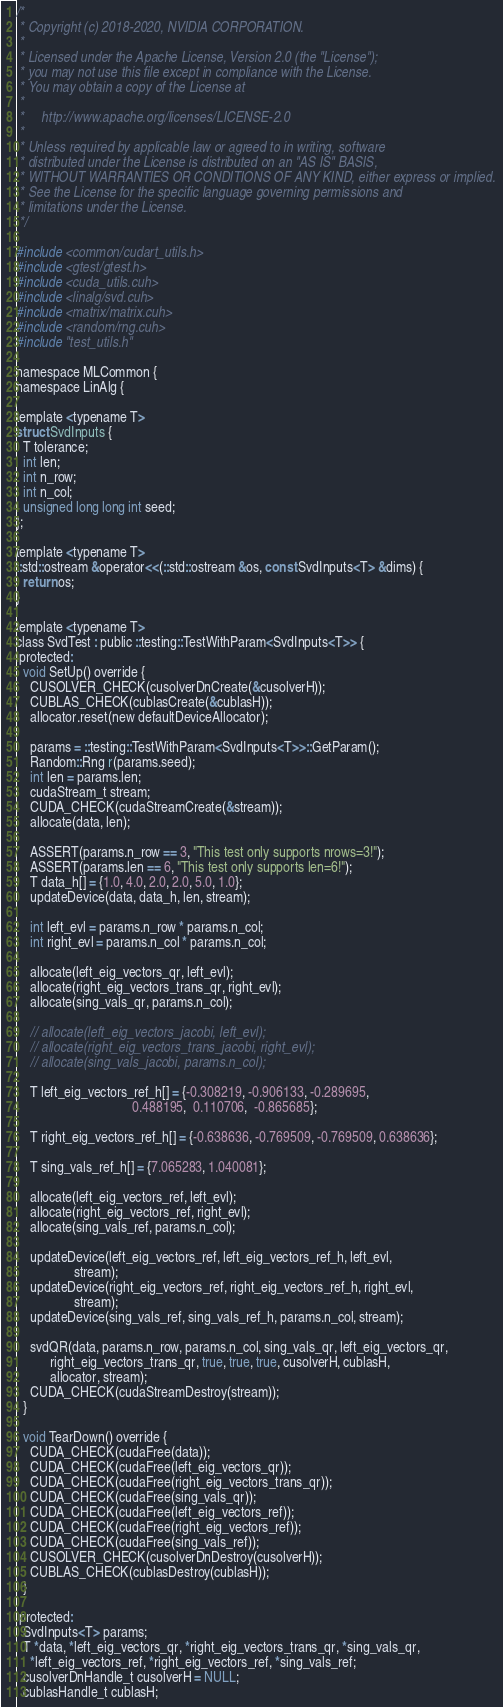Convert code to text. <code><loc_0><loc_0><loc_500><loc_500><_Cuda_>/*
 * Copyright (c) 2018-2020, NVIDIA CORPORATION.
 *
 * Licensed under the Apache License, Version 2.0 (the "License");
 * you may not use this file except in compliance with the License.
 * You may obtain a copy of the License at
 *
 *     http://www.apache.org/licenses/LICENSE-2.0
 *
 * Unless required by applicable law or agreed to in writing, software
 * distributed under the License is distributed on an "AS IS" BASIS,
 * WITHOUT WARRANTIES OR CONDITIONS OF ANY KIND, either express or implied.
 * See the License for the specific language governing permissions and
 * limitations under the License.
 */

#include <common/cudart_utils.h>
#include <gtest/gtest.h>
#include <cuda_utils.cuh>
#include <linalg/svd.cuh>
#include <matrix/matrix.cuh>
#include <random/rng.cuh>
#include "test_utils.h"

namespace MLCommon {
namespace LinAlg {

template <typename T>
struct SvdInputs {
  T tolerance;
  int len;
  int n_row;
  int n_col;
  unsigned long long int seed;
};

template <typename T>
::std::ostream &operator<<(::std::ostream &os, const SvdInputs<T> &dims) {
  return os;
}

template <typename T>
class SvdTest : public ::testing::TestWithParam<SvdInputs<T>> {
 protected:
  void SetUp() override {
    CUSOLVER_CHECK(cusolverDnCreate(&cusolverH));
    CUBLAS_CHECK(cublasCreate(&cublasH));
    allocator.reset(new defaultDeviceAllocator);

    params = ::testing::TestWithParam<SvdInputs<T>>::GetParam();
    Random::Rng r(params.seed);
    int len = params.len;
    cudaStream_t stream;
    CUDA_CHECK(cudaStreamCreate(&stream));
    allocate(data, len);

    ASSERT(params.n_row == 3, "This test only supports nrows=3!");
    ASSERT(params.len == 6, "This test only supports len=6!");
    T data_h[] = {1.0, 4.0, 2.0, 2.0, 5.0, 1.0};
    updateDevice(data, data_h, len, stream);

    int left_evl = params.n_row * params.n_col;
    int right_evl = params.n_col * params.n_col;

    allocate(left_eig_vectors_qr, left_evl);
    allocate(right_eig_vectors_trans_qr, right_evl);
    allocate(sing_vals_qr, params.n_col);

    // allocate(left_eig_vectors_jacobi, left_evl);
    // allocate(right_eig_vectors_trans_jacobi, right_evl);
    // allocate(sing_vals_jacobi, params.n_col);

    T left_eig_vectors_ref_h[] = {-0.308219, -0.906133, -0.289695,
                                  0.488195,  0.110706,  -0.865685};

    T right_eig_vectors_ref_h[] = {-0.638636, -0.769509, -0.769509, 0.638636};

    T sing_vals_ref_h[] = {7.065283, 1.040081};

    allocate(left_eig_vectors_ref, left_evl);
    allocate(right_eig_vectors_ref, right_evl);
    allocate(sing_vals_ref, params.n_col);

    updateDevice(left_eig_vectors_ref, left_eig_vectors_ref_h, left_evl,
                 stream);
    updateDevice(right_eig_vectors_ref, right_eig_vectors_ref_h, right_evl,
                 stream);
    updateDevice(sing_vals_ref, sing_vals_ref_h, params.n_col, stream);

    svdQR(data, params.n_row, params.n_col, sing_vals_qr, left_eig_vectors_qr,
          right_eig_vectors_trans_qr, true, true, true, cusolverH, cublasH,
          allocator, stream);
    CUDA_CHECK(cudaStreamDestroy(stream));
  }

  void TearDown() override {
    CUDA_CHECK(cudaFree(data));
    CUDA_CHECK(cudaFree(left_eig_vectors_qr));
    CUDA_CHECK(cudaFree(right_eig_vectors_trans_qr));
    CUDA_CHECK(cudaFree(sing_vals_qr));
    CUDA_CHECK(cudaFree(left_eig_vectors_ref));
    CUDA_CHECK(cudaFree(right_eig_vectors_ref));
    CUDA_CHECK(cudaFree(sing_vals_ref));
    CUSOLVER_CHECK(cusolverDnDestroy(cusolverH));
    CUBLAS_CHECK(cublasDestroy(cublasH));
  }

 protected:
  SvdInputs<T> params;
  T *data, *left_eig_vectors_qr, *right_eig_vectors_trans_qr, *sing_vals_qr,
    *left_eig_vectors_ref, *right_eig_vectors_ref, *sing_vals_ref;
  cusolverDnHandle_t cusolverH = NULL;
  cublasHandle_t cublasH;</code> 